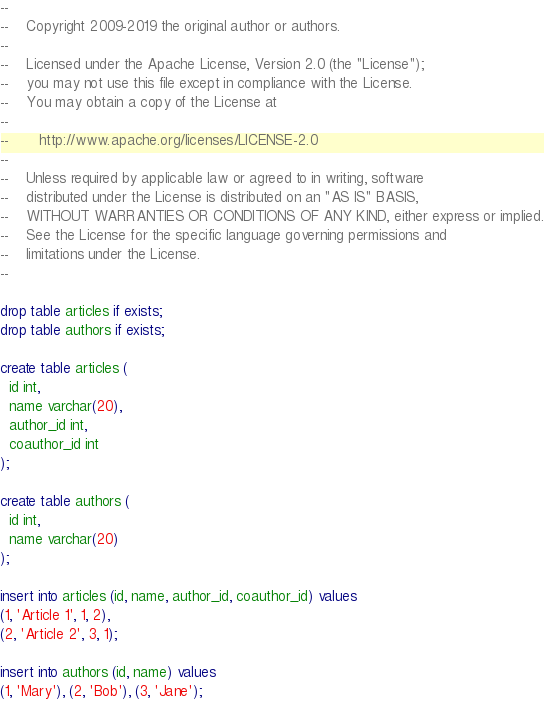<code> <loc_0><loc_0><loc_500><loc_500><_SQL_>--
--    Copyright 2009-2019 the original author or authors.
--
--    Licensed under the Apache License, Version 2.0 (the "License");
--    you may not use this file except in compliance with the License.
--    You may obtain a copy of the License at
--
--       http://www.apache.org/licenses/LICENSE-2.0
--
--    Unless required by applicable law or agreed to in writing, software
--    distributed under the License is distributed on an "AS IS" BASIS,
--    WITHOUT WARRANTIES OR CONDITIONS OF ANY KIND, either express or implied.
--    See the License for the specific language governing permissions and
--    limitations under the License.
--

drop table articles if exists;
drop table authors if exists;

create table articles (
  id int,
  name varchar(20),
  author_id int,
  coauthor_id int
);

create table authors (
  id int,
  name varchar(20)
);

insert into articles (id, name, author_id, coauthor_id) values
(1, 'Article 1', 1, 2),
(2, 'Article 2', 3, 1);

insert into authors (id, name) values
(1, 'Mary'), (2, 'Bob'), (3, 'Jane');
</code> 